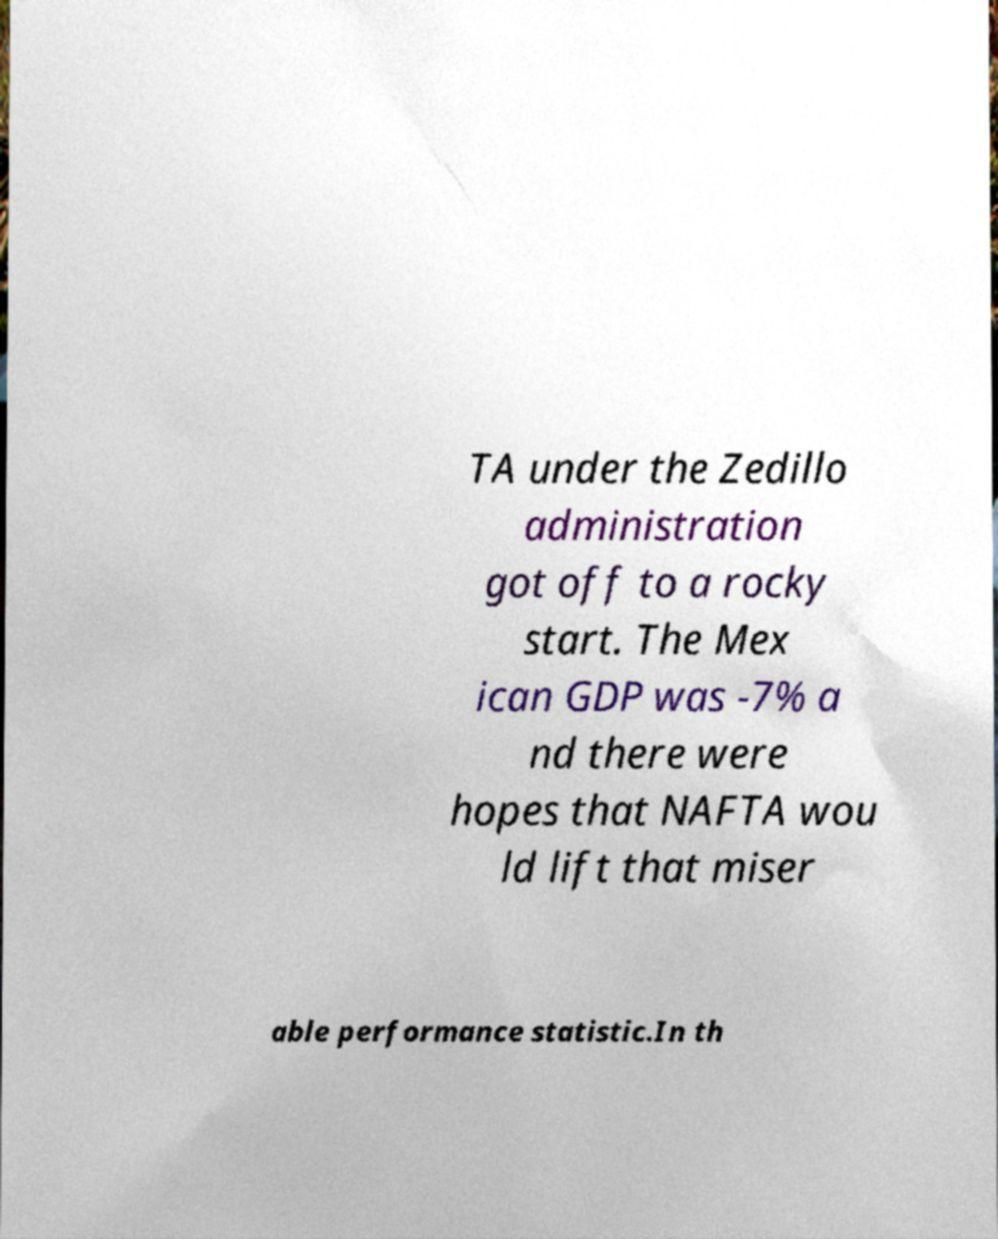Please identify and transcribe the text found in this image. TA under the Zedillo administration got off to a rocky start. The Mex ican GDP was -7% a nd there were hopes that NAFTA wou ld lift that miser able performance statistic.In th 